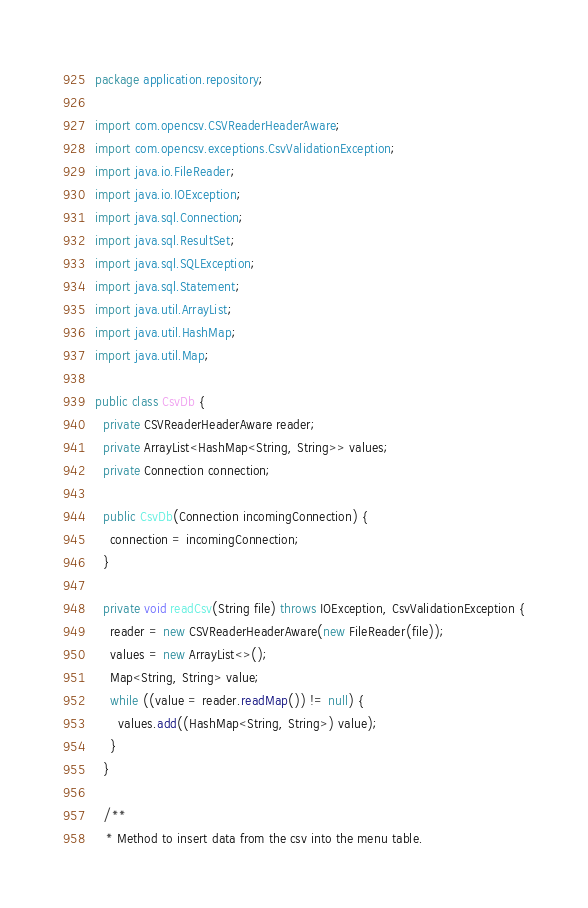<code> <loc_0><loc_0><loc_500><loc_500><_Java_>package application.repository;

import com.opencsv.CSVReaderHeaderAware;
import com.opencsv.exceptions.CsvValidationException;
import java.io.FileReader;
import java.io.IOException;
import java.sql.Connection;
import java.sql.ResultSet;
import java.sql.SQLException;
import java.sql.Statement;
import java.util.ArrayList;
import java.util.HashMap;
import java.util.Map;

public class CsvDb {
  private CSVReaderHeaderAware reader;
  private ArrayList<HashMap<String, String>> values;
  private Connection connection;

  public CsvDb(Connection incomingConnection) {
    connection = incomingConnection;
  }

  private void readCsv(String file) throws IOException, CsvValidationException {
    reader = new CSVReaderHeaderAware(new FileReader(file));
    values = new ArrayList<>();
    Map<String, String> value;
    while ((value = reader.readMap()) != null) {
      values.add((HashMap<String, String>) value);
    }
  }

  /**
   * Method to insert data from the csv into the menu table.</code> 